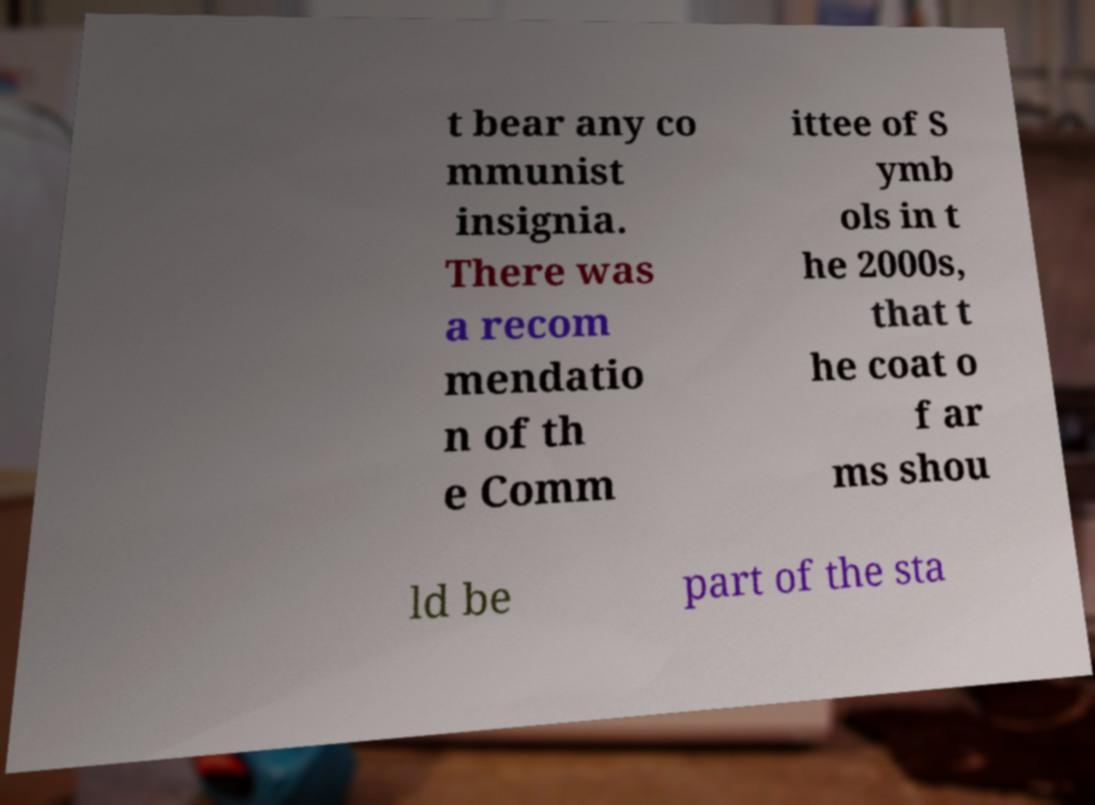Can you accurately transcribe the text from the provided image for me? t bear any co mmunist insignia. There was a recom mendatio n of th e Comm ittee of S ymb ols in t he 2000s, that t he coat o f ar ms shou ld be part of the sta 